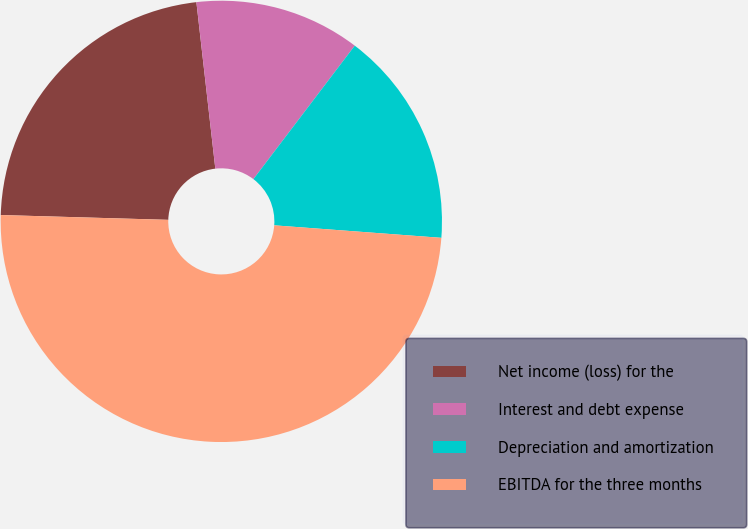<chart> <loc_0><loc_0><loc_500><loc_500><pie_chart><fcel>Net income (loss) for the<fcel>Interest and debt expense<fcel>Depreciation and amortization<fcel>EBITDA for the three months<nl><fcel>22.74%<fcel>12.14%<fcel>15.85%<fcel>49.27%<nl></chart> 